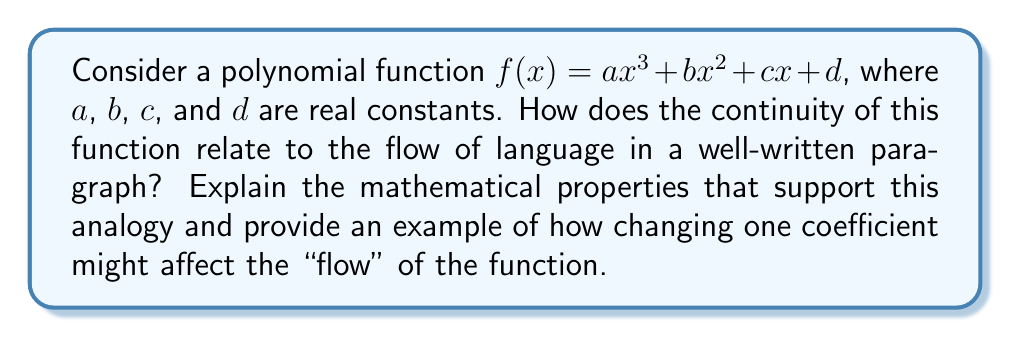Could you help me with this problem? 1. Continuity of polynomial functions:
   - All polynomial functions are continuous over their entire domain (all real numbers).
   - This means there are no breaks, gaps, or jumps in the graph of $f(x)$.

2. Relation to language flow:
   - Continuous functions can be likened to smooth, uninterrupted prose.
   - Each term in the polynomial contributes to the overall shape, similar to how different sentence structures contribute to paragraph flow.

3. Properties supporting the analogy:
   a. Differentiability: Polynomials are infinitely differentiable, allowing for smooth transitions (like well-connected ideas in writing).
   b. No vertical asymptotes: Ensures no abrupt "breaks" in the function (similar to avoiding jarring transitions in writing).
   c. Gradual changes in slope: Reflects the natural progression of ideas in a paragraph.

4. Example of changing a coefficient:
   Let's consider $f(x) = x^3 - 3x^2 + 2x + 1$
   
   Changing the coefficient of $x^2$ from -3 to -5:
   $g(x) = x^3 - 5x^2 + 2x + 1$

   [asy]
   import graph;
   size(200,200);
   
   real f(real x) {return x^3 - 3x^2 + 2x + 1;}
   real g(real x) {return x^3 - 5x^2 + 2x + 1;}
   
   draw(graph(f,-1,3), blue);
   draw(graph(g,-1,3), red);
   
   xaxis("x");
   yaxis("y");
   
   label("f(x)", (2.5,f(2.5)), NE, blue);
   label("g(x)", (2.5,g(2.5)), SE, red);
   [/asy]

   This change affects the "flow" of the function by:
   - Altering the location and depth of the local minimum
   - Changing the rate of increase after the minimum point
   - Shifting the overall shape of the curve

   In terms of writing, this could be analogous to changing the emphasis or pacing of a particular section within a paragraph, affecting how ideas transition and flow from one to another.
Answer: Polynomial continuity mirrors language flow; changing coefficients alters the function's shape, analogous to modifying sentence structure or emphasis in writing. 